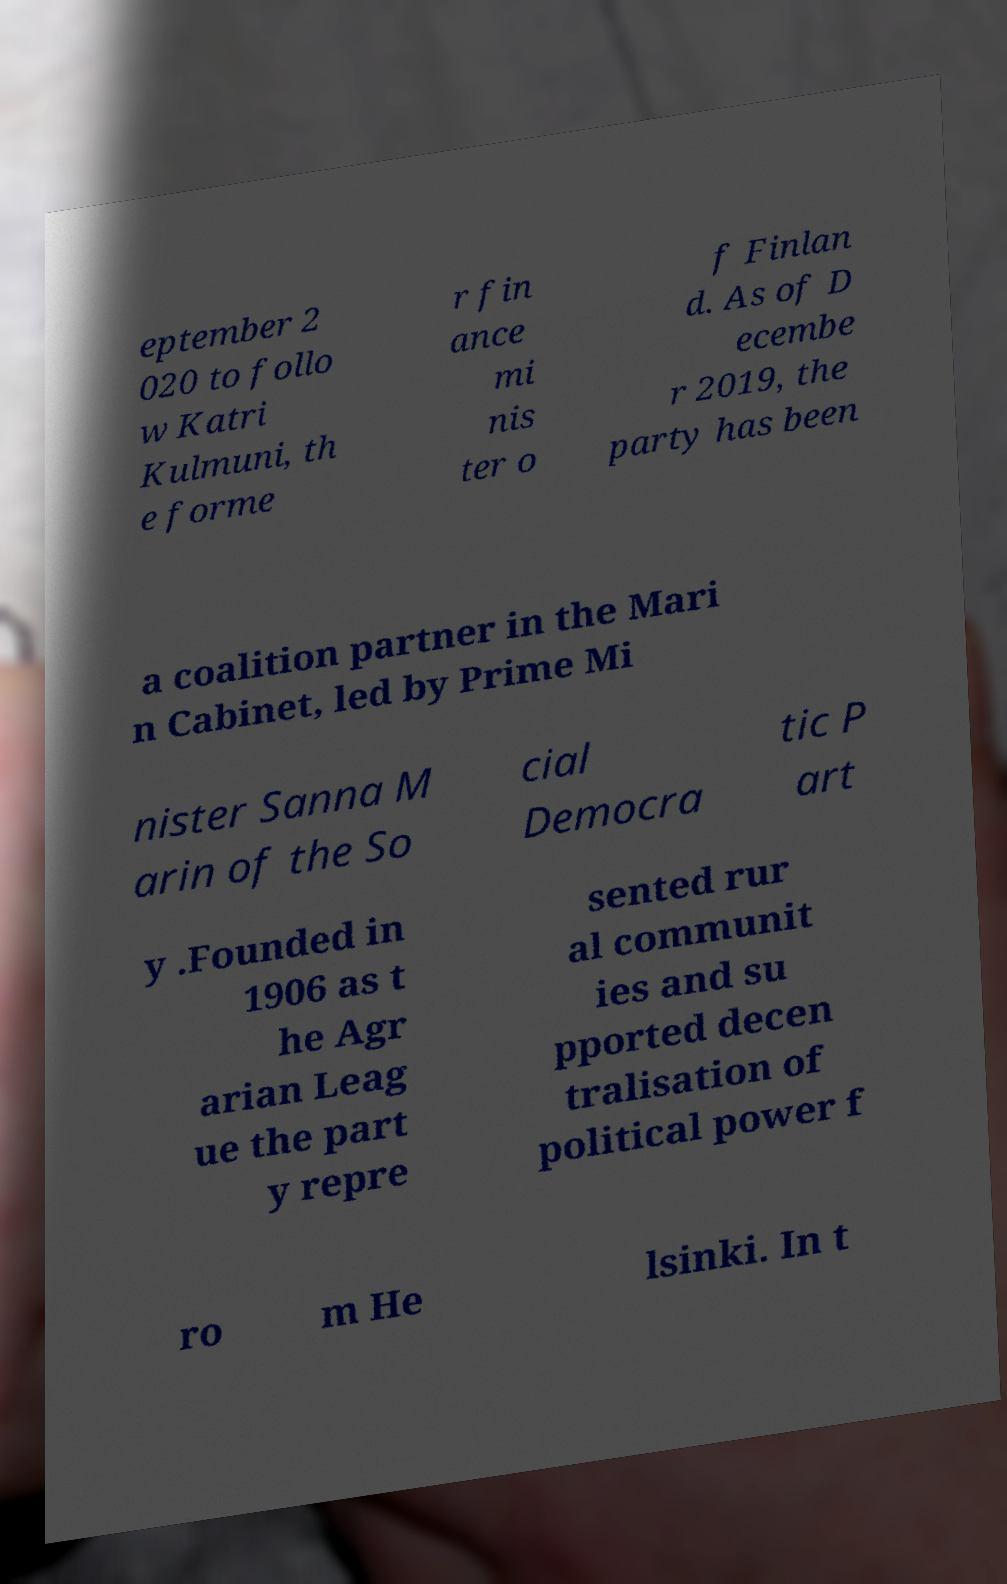Please read and relay the text visible in this image. What does it say? eptember 2 020 to follo w Katri Kulmuni, th e forme r fin ance mi nis ter o f Finlan d. As of D ecembe r 2019, the party has been a coalition partner in the Mari n Cabinet, led by Prime Mi nister Sanna M arin of the So cial Democra tic P art y .Founded in 1906 as t he Agr arian Leag ue the part y repre sented rur al communit ies and su pported decen tralisation of political power f ro m He lsinki. In t 